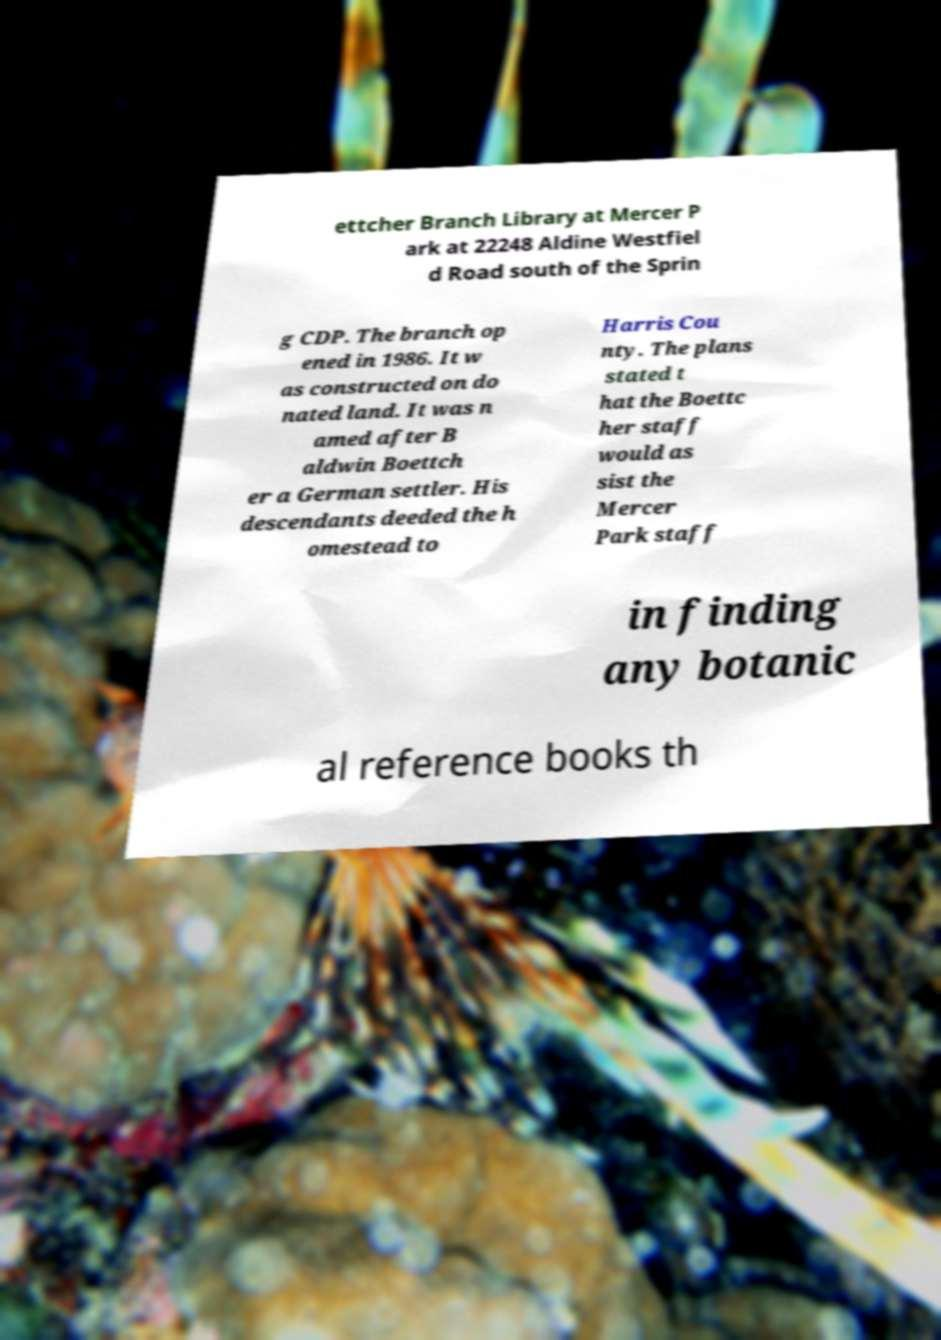Could you assist in decoding the text presented in this image and type it out clearly? ettcher Branch Library at Mercer P ark at 22248 Aldine Westfiel d Road south of the Sprin g CDP. The branch op ened in 1986. It w as constructed on do nated land. It was n amed after B aldwin Boettch er a German settler. His descendants deeded the h omestead to Harris Cou nty. The plans stated t hat the Boettc her staff would as sist the Mercer Park staff in finding any botanic al reference books th 